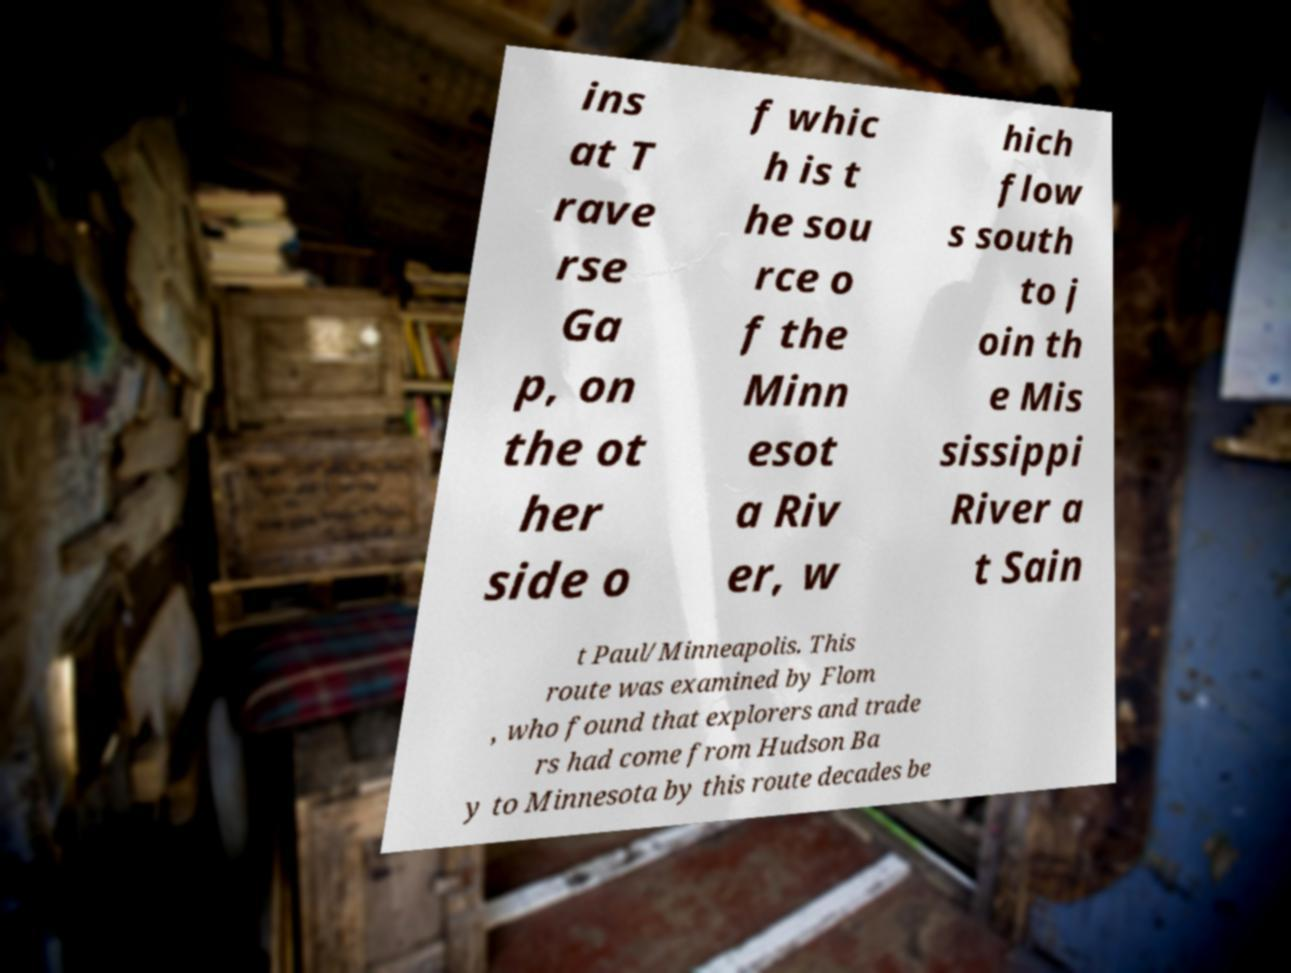What messages or text are displayed in this image? I need them in a readable, typed format. ins at T rave rse Ga p, on the ot her side o f whic h is t he sou rce o f the Minn esot a Riv er, w hich flow s south to j oin th e Mis sissippi River a t Sain t Paul/Minneapolis. This route was examined by Flom , who found that explorers and trade rs had come from Hudson Ba y to Minnesota by this route decades be 